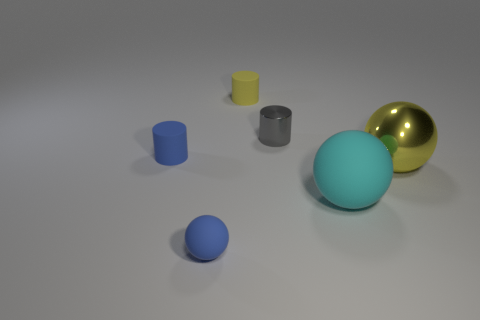Subtract all cyan spheres. How many spheres are left? 2 Subtract all yellow balls. How many balls are left? 2 Subtract 3 balls. How many balls are left? 0 Add 3 large metallic spheres. How many objects exist? 9 Subtract 0 green cubes. How many objects are left? 6 Subtract all cyan balls. Subtract all blue cylinders. How many balls are left? 2 Subtract all blue blocks. How many yellow balls are left? 1 Subtract all large yellow spheres. Subtract all yellow metal balls. How many objects are left? 4 Add 6 tiny blue cylinders. How many tiny blue cylinders are left? 7 Add 6 yellow metal spheres. How many yellow metal spheres exist? 7 